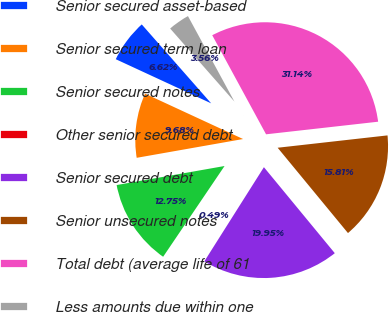Convert chart to OTSL. <chart><loc_0><loc_0><loc_500><loc_500><pie_chart><fcel>Senior secured asset-based<fcel>Senior secured term loan<fcel>Senior secured notes<fcel>Other senior secured debt<fcel>Senior secured debt<fcel>Senior unsecured notes<fcel>Total debt (average life of 61<fcel>Less amounts due within one<nl><fcel>6.62%<fcel>9.68%<fcel>12.75%<fcel>0.49%<fcel>19.95%<fcel>15.81%<fcel>31.14%<fcel>3.56%<nl></chart> 